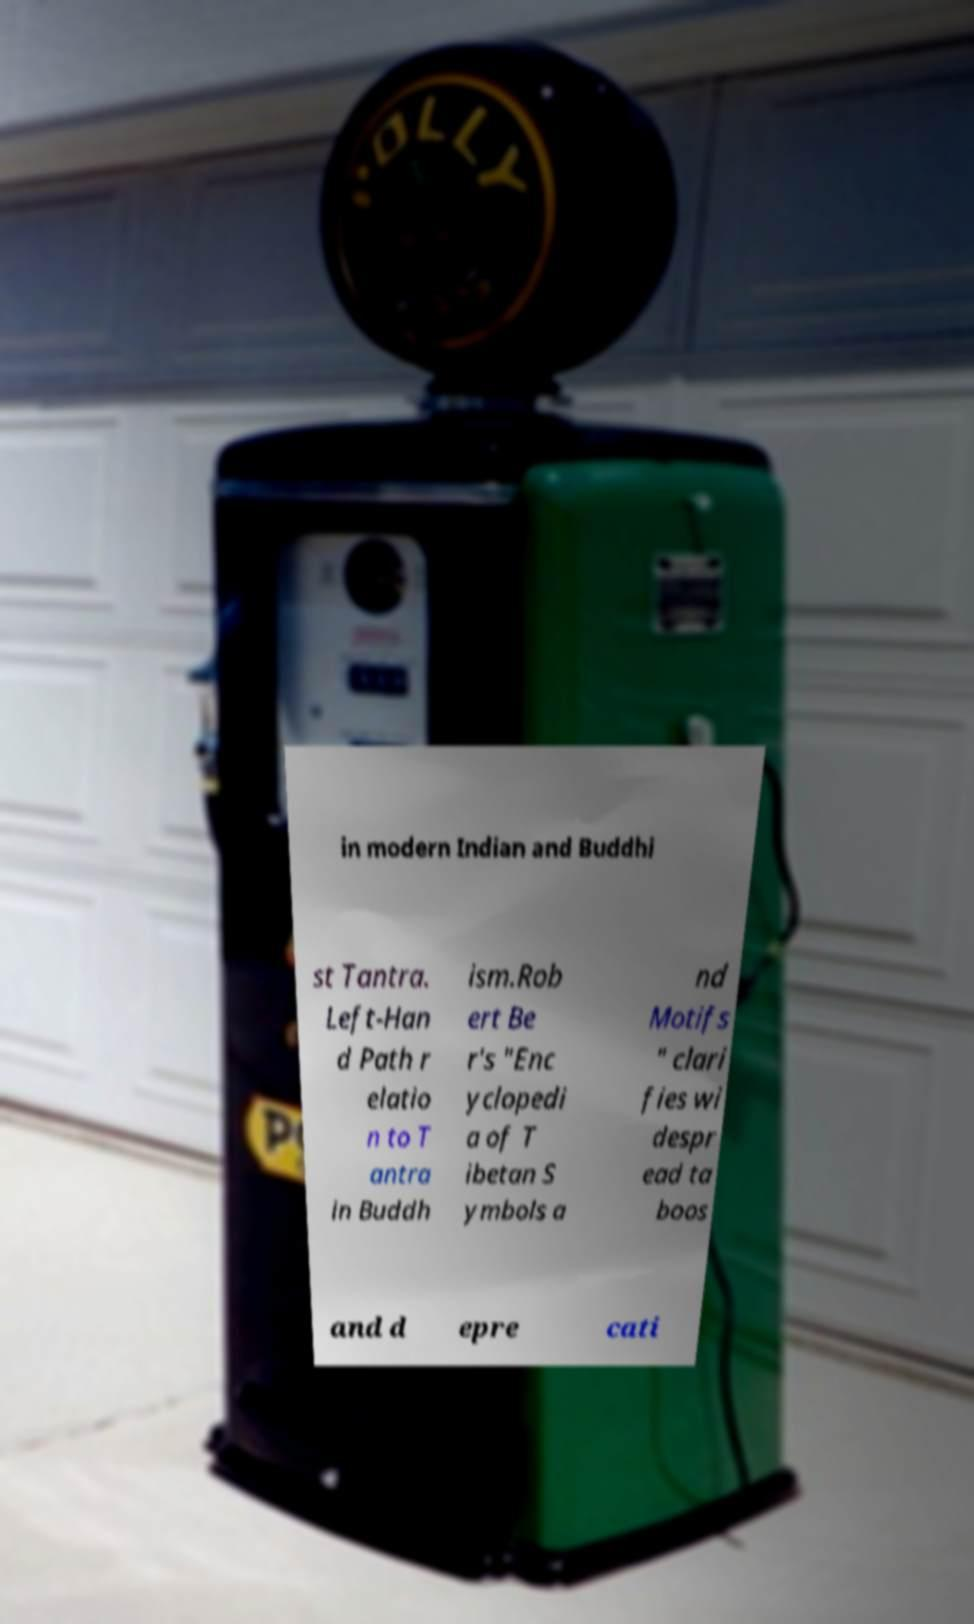Can you read and provide the text displayed in the image?This photo seems to have some interesting text. Can you extract and type it out for me? in modern Indian and Buddhi st Tantra. Left-Han d Path r elatio n to T antra in Buddh ism.Rob ert Be r's "Enc yclopedi a of T ibetan S ymbols a nd Motifs " clari fies wi despr ead ta boos and d epre cati 